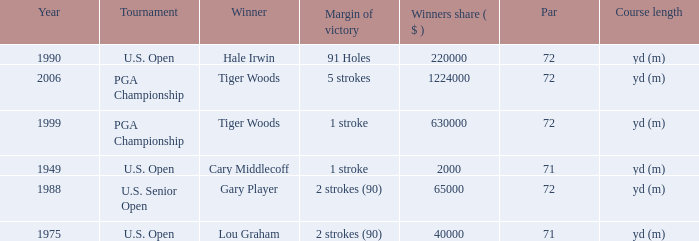When cary middlecoff is the winner how many pars are there? 1.0. 